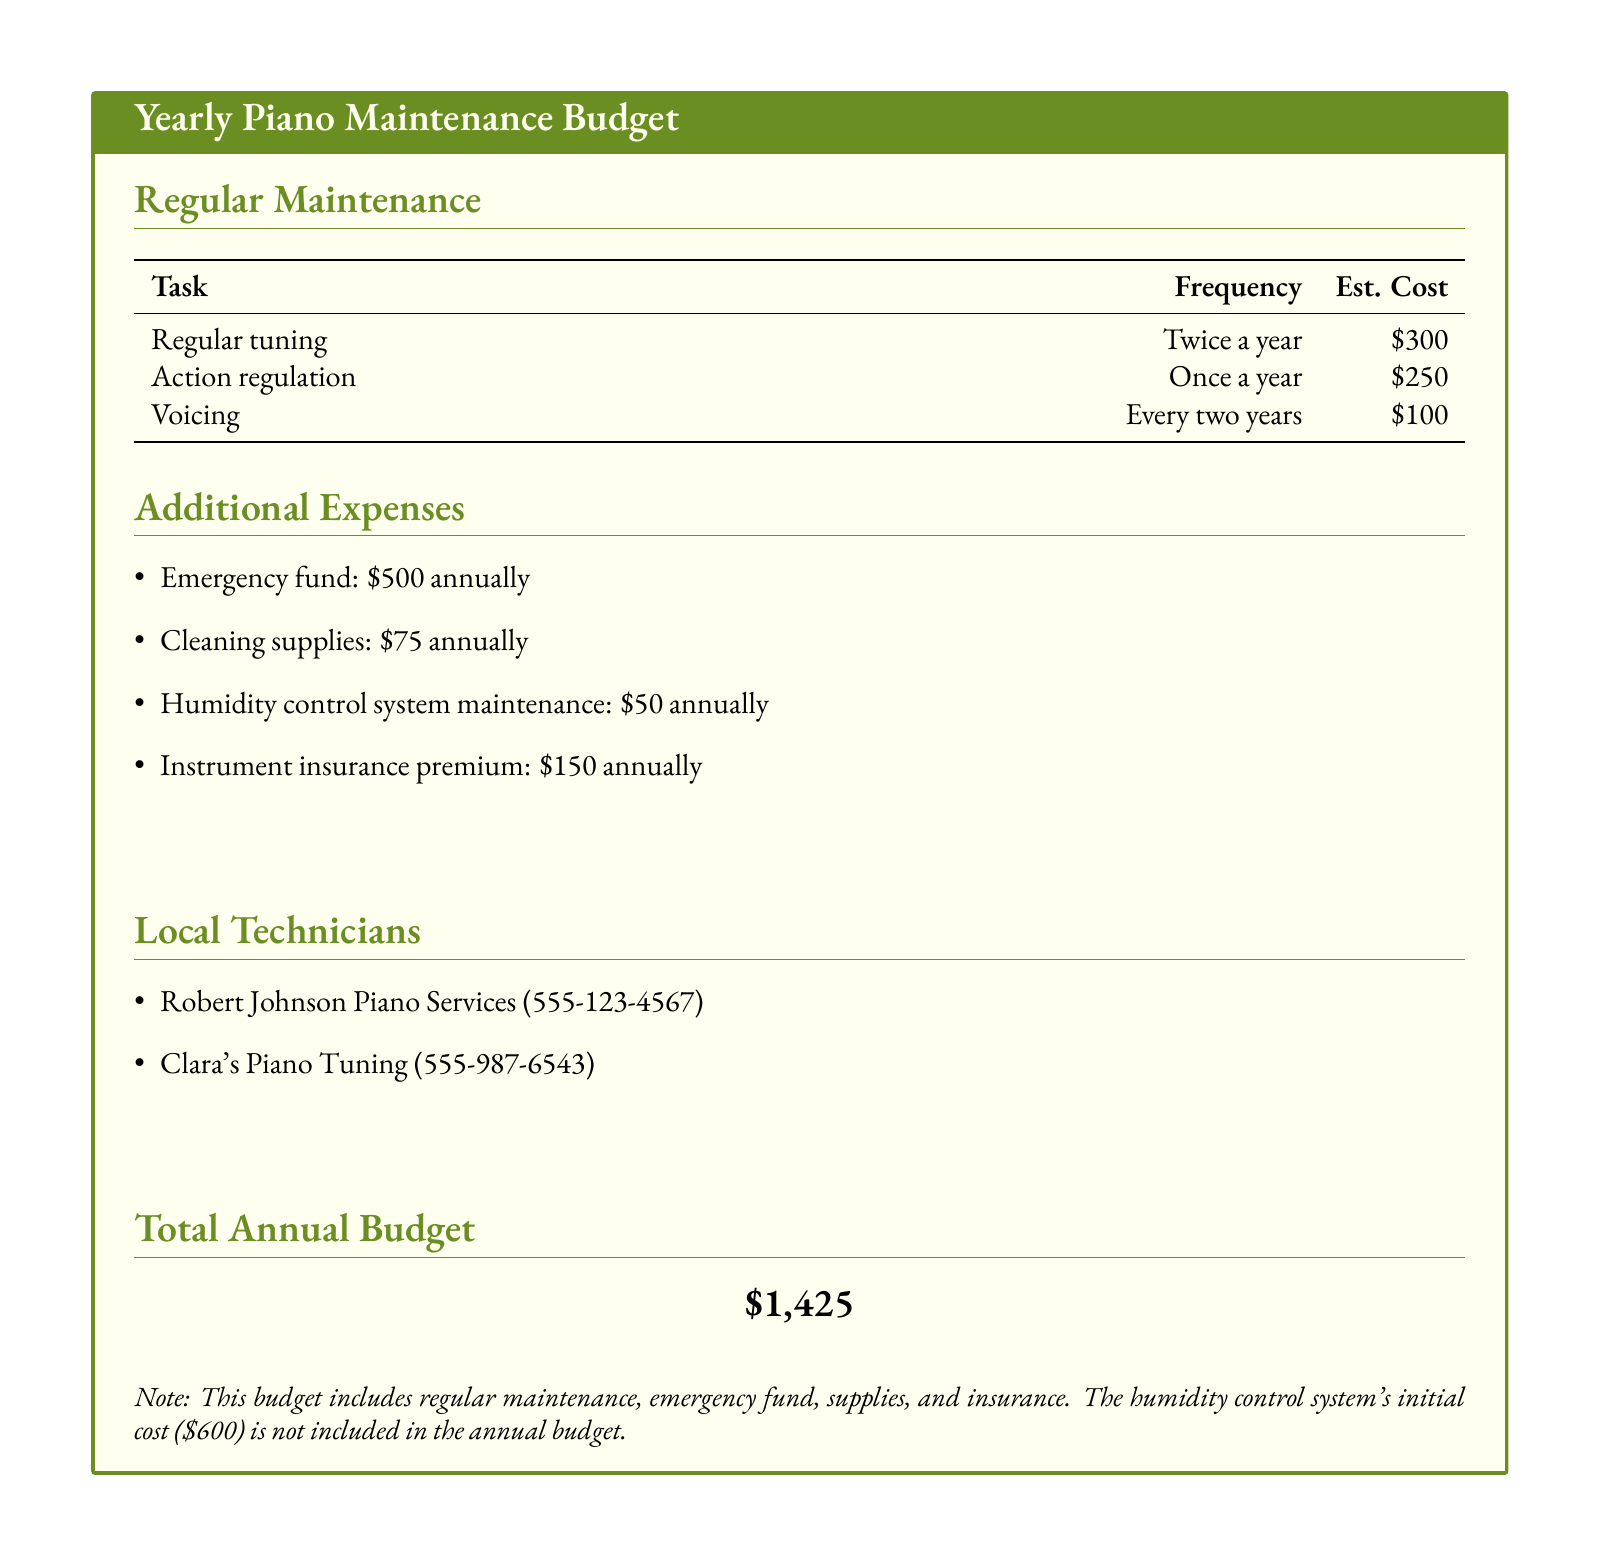What is the estimated cost for regular tuning? The estimated cost for regular tuning can be found in the "Regular Maintenance" section, which lists it as $300.
Answer: $300 How many times a year is action regulation scheduled? The frequency for action regulation is indicated in the "Regular Maintenance" section, listed as once a year.
Answer: Once a year What is the total annual budget for maintaining the piano? The total annual budget is summarized at the end of the document, which states it as $1,425.
Answer: $1,425 What is the cost of the emergency fund listed in the document? The emergency fund cost is mentioned in the "Additional Expenses" section as $500 annually.
Answer: $500 How often is voicing scheduled? Voicing frequency is mentioned in the "Regular Maintenance" section, which states it is every two years.
Answer: Every two years What is listed as an additional annual expense for humidity control? The "Additional Expenses" section specifies the cost for humidity control system maintenance as $50 annually.
Answer: $50 Who are the local technicians listed for piano maintenance? The document lists two local technicians: Robert Johnson Piano Services and Clara's Piano Tuning.
Answer: Robert Johnson Piano Services, Clara's Piano Tuning What is the estimated cost for cleaning supplies? The estimated cost for cleaning supplies is found in the "Additional Expenses" section, listed as $75 annually.
Answer: $75 What is the insurance premium cost mentioned in the budget? The insurance premium cost is indicated in the "Additional Expenses" section as $150 annually.
Answer: $150 